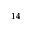Convert formula to latex. <formula><loc_0><loc_0><loc_500><loc_500>^ { 1 4 }</formula> 